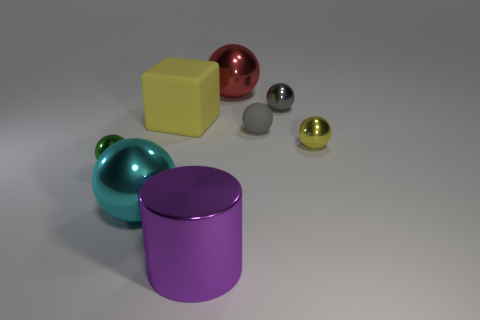Subtract all green spheres. How many spheres are left? 5 Subtract all small gray metal balls. How many balls are left? 5 Subtract all green spheres. Subtract all cyan cubes. How many spheres are left? 5 Add 1 large yellow rubber things. How many objects exist? 9 Subtract all cubes. How many objects are left? 7 Add 5 yellow matte things. How many yellow matte things are left? 6 Add 4 rubber cylinders. How many rubber cylinders exist? 4 Subtract 1 purple cylinders. How many objects are left? 7 Subtract all small yellow shiny balls. Subtract all yellow spheres. How many objects are left? 6 